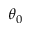Convert formula to latex. <formula><loc_0><loc_0><loc_500><loc_500>\theta _ { 0 }</formula> 